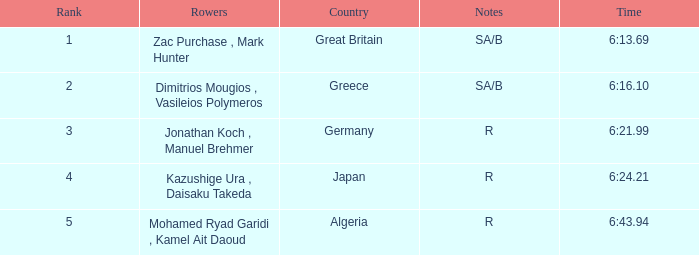What are the notes with the time 6:24.21? R. 